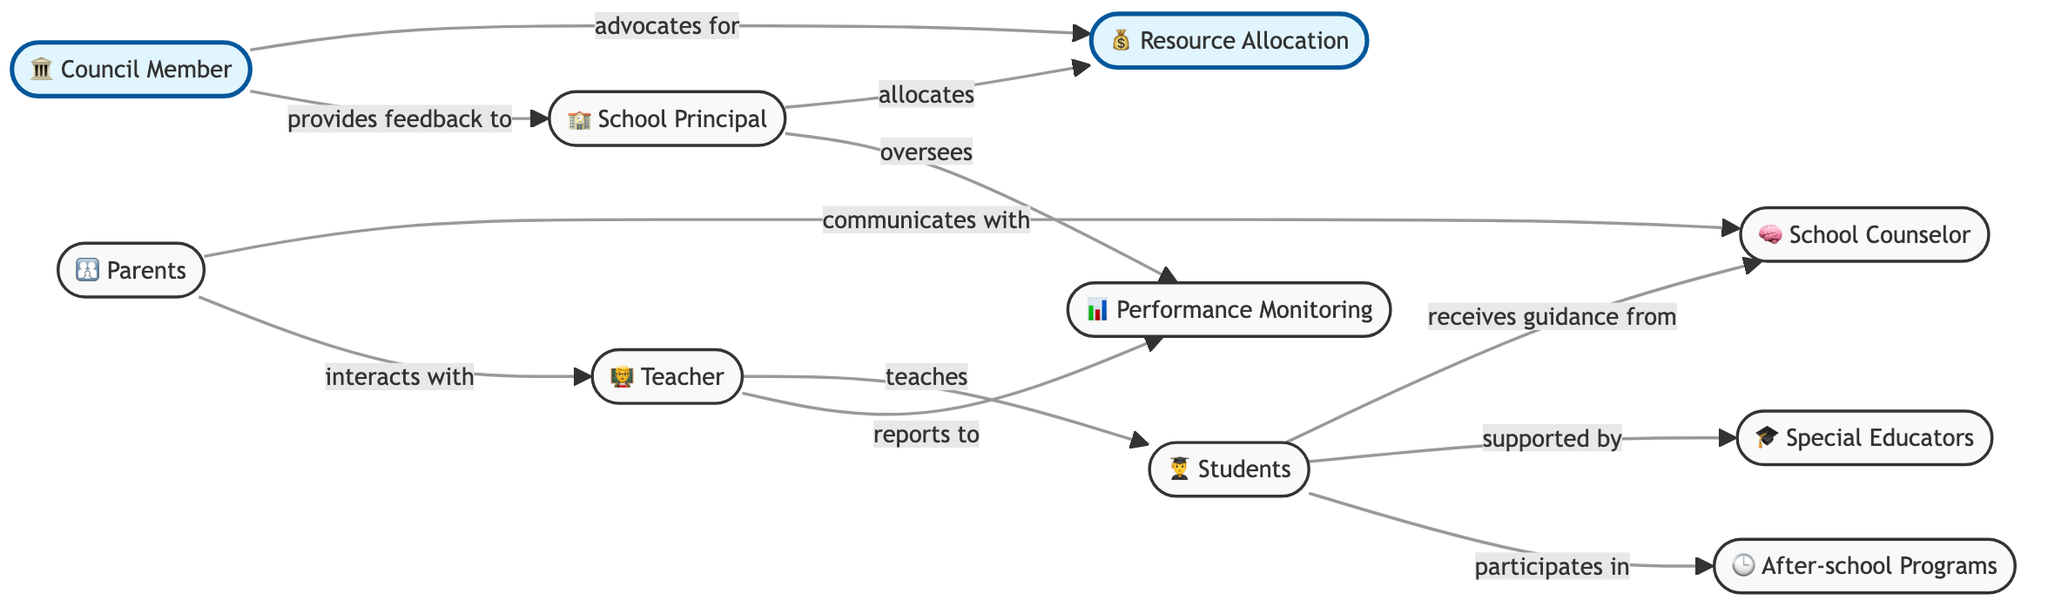What is the total number of nodes in this network diagram? The diagram consists of a list of nodes that includes Teacher, Students, Council Member, School Counselor, Parents, Special Educators, School Principal, Resource Allocation, Performance Monitoring, and After-school Programs. Counting these gives a total of ten nodes.
Answer: 10 Which node does the Council Member advocate for? The Council Member has a direct link to the Resource Allocation node, which signifies their role in advocating for it.
Answer: Resource Allocation Who do the students receive guidance from? In the diagram, there is a direct connection between Students and School Counselor labeled "receives guidance from." This indicates that the School Counselor provides support to the students.
Answer: School Counselor What role does the School Principal have with Performance Monitoring? The School Principal oversees the Performance Monitoring node, as indicated by the connection labeled "oversees." This suggests the principal's involvement in monitoring student performance.
Answer: Oversees How many links are there in total connecting the different nodes? Each connection between nodes represents a link. By counting the links listed in the data, we find there are ten connections: Teacher to Students, Council Member to Resource Allocation, and so on.
Answer: 10 What is the relationship between Students and Special Educators? The relationship is established through a link labeled "supported by," which means that Special Educators provide support to the Students in some capacity.
Answer: Supported by Who interacts with the Teacher aside from the Student? The diagram indicates that Parents also have an interaction with the Teacher, as represented by the link labeled "interacts with." This shows the connection between parents and the teaching staff.
Answer: Parents What feedback does the Council Member provide? The Council Member provides feedback to the School Principal, which is signified by the link labeled "provides feedback to." This indicates a communication channel for support or suggestions regarding school matters.
Answer: Provides feedback to Which two nodes are directly associated with after-school programs? The Students node is directly connected to After-school Programs with a link labeled "participates in," highlighting that students are involved in these programs.
Answer: Students and After-school Programs 